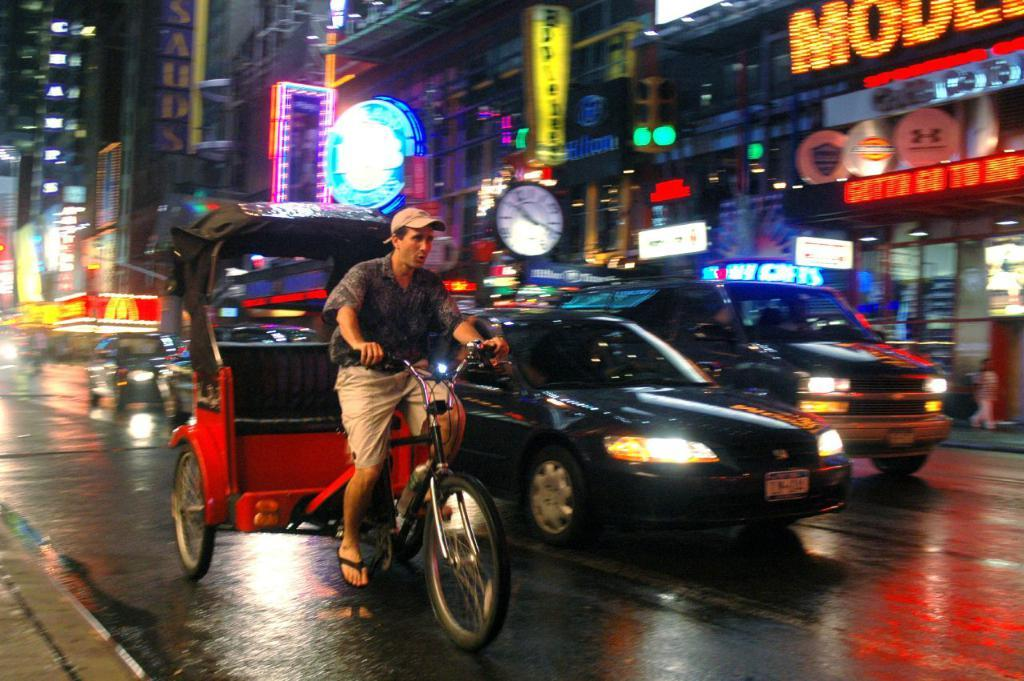<image>
Describe the image concisely. A man pedals a carriage through the streets of NYC with the McDonald's arches in the background. 